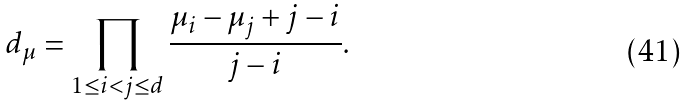<formula> <loc_0><loc_0><loc_500><loc_500>d _ { \mu } = \prod _ { 1 \leq i < j \leq d } \frac { \mu _ { i } - \mu _ { j } + j - i } { j - i } .</formula> 